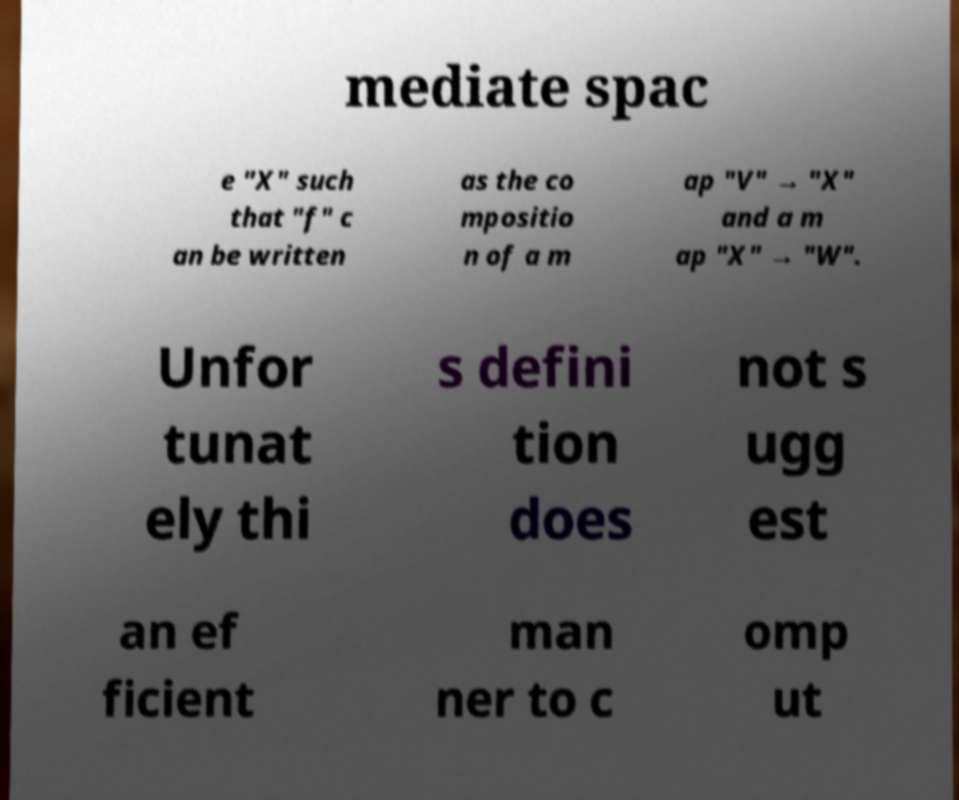Please read and relay the text visible in this image. What does it say? mediate spac e "X" such that "f" c an be written as the co mpositio n of a m ap "V" → "X" and a m ap "X" → "W". Unfor tunat ely thi s defini tion does not s ugg est an ef ficient man ner to c omp ut 